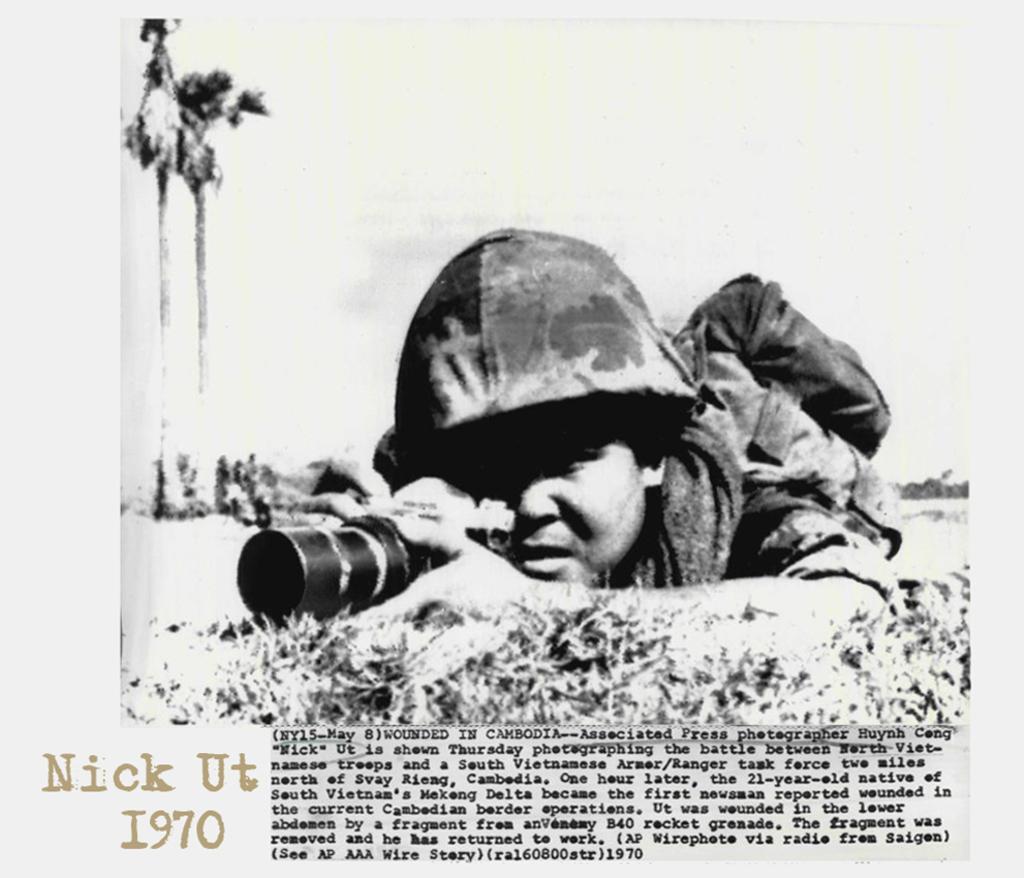Could you give a brief overview of what you see in this image? This is a black and white image. In this image there is a person wearing helmet is holding a bag and camera. On the left side there are trees. Also something is written on the image. 